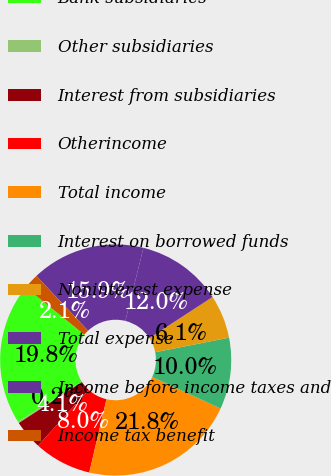Convert chart to OTSL. <chart><loc_0><loc_0><loc_500><loc_500><pie_chart><fcel>Bank subsidiaries<fcel>Other subsidiaries<fcel>Interest from subsidiaries<fcel>Otherincome<fcel>Total income<fcel>Interest on borrowed funds<fcel>Noninterest expense<fcel>Total expense<fcel>Income before income taxes and<fcel>Income tax benefit<nl><fcel>19.81%<fcel>0.19%<fcel>4.11%<fcel>8.04%<fcel>21.77%<fcel>10.0%<fcel>6.08%<fcel>11.96%<fcel>15.89%<fcel>2.15%<nl></chart> 